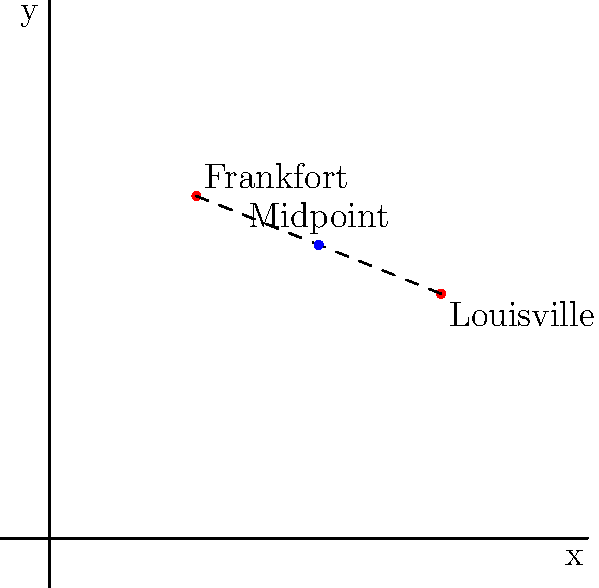On the coordinate grid representing Kentucky, Frankfort is located at $(3,7)$ and Louisville is at $(8,5)$. Find the coordinates of the midpoint between these two cities. To find the midpoint between two points, we use the midpoint formula:

$$ \text{Midpoint} = \left(\frac{x_1 + x_2}{2}, \frac{y_1 + y_2}{2}\right) $$

Where $(x_1, y_1)$ are the coordinates of the first point and $(x_2, y_2)$ are the coordinates of the second point.

For Frankfort: $(x_1, y_1) = (3, 7)$
For Louisville: $(x_2, y_2) = (8, 5)$

Applying the formula:

1. x-coordinate of midpoint:
   $$ \frac{x_1 + x_2}{2} = \frac{3 + 8}{2} = \frac{11}{2} = 5.5 $$

2. y-coordinate of midpoint:
   $$ \frac{y_1 + y_2}{2} = \frac{7 + 5}{2} = \frac{12}{2} = 6 $$

Therefore, the midpoint between Frankfort and Louisville is $(5.5, 6)$.
Answer: $(5.5, 6)$ 